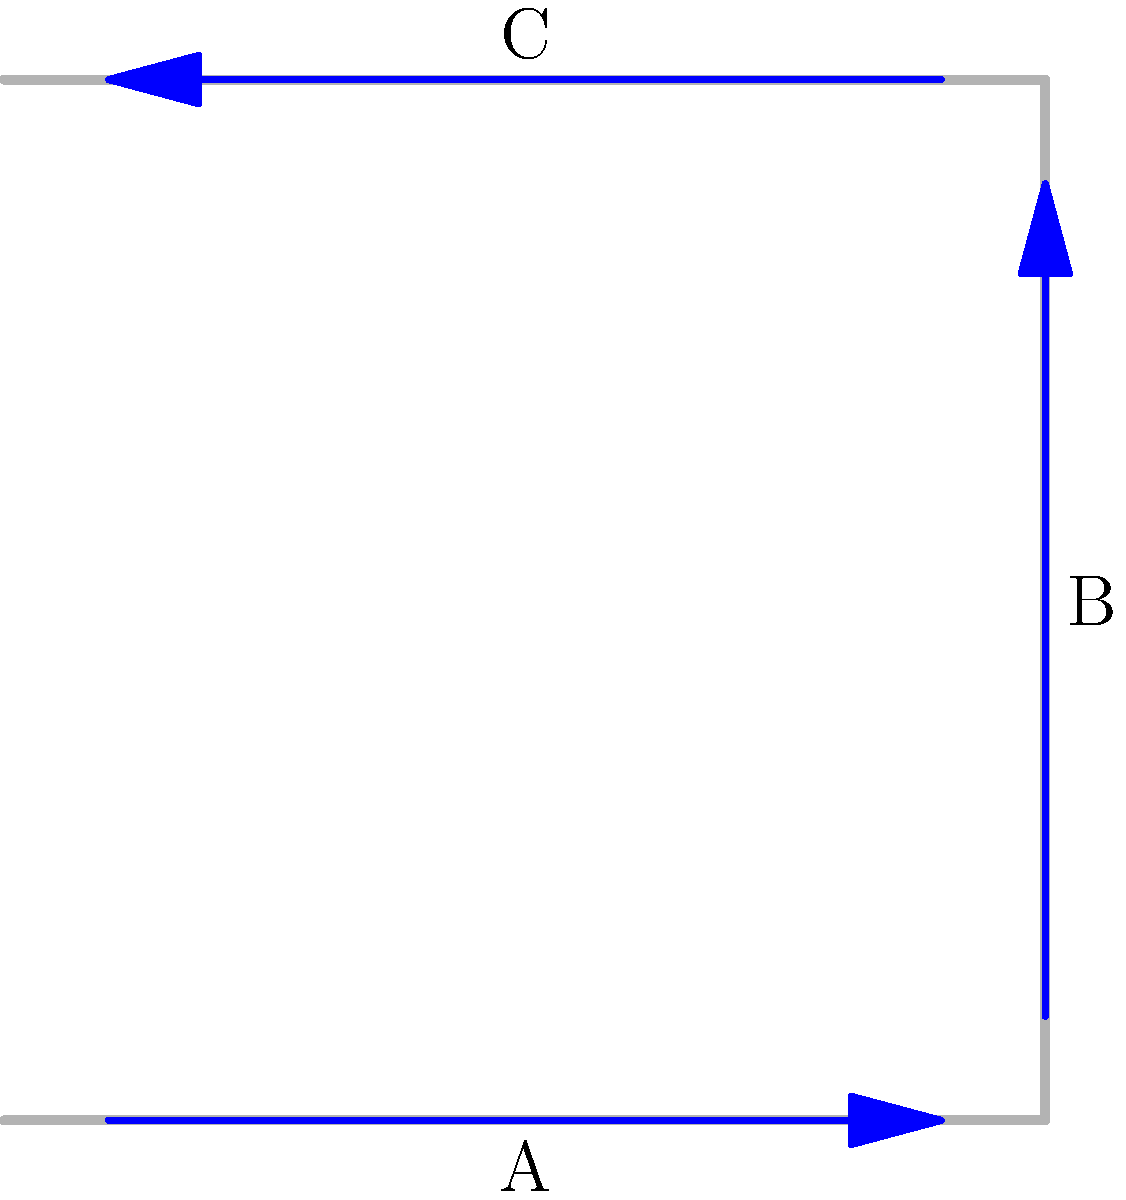In the pipe configuration shown above, fluid flows from point A to point C. Assuming steady, incompressible flow and neglecting friction, how does the fluid velocity at point B compare to the velocities at points A and C? To answer this question, we need to apply the principles of fluid dynamics, specifically the continuity equation and Bernoulli's principle:

1. Continuity Equation: For incompressible flow, the mass flow rate must be constant throughout the system. This means:

   $$Q = A_1v_1 = A_2v_2 = A_3v_3$$

   Where $Q$ is the volumetric flow rate, $A$ is the cross-sectional area, and $v$ is the velocity.

2. Assuming the pipe has a constant diameter, the cross-sectional area is the same at all points (A, B, and C).

3. The flow direction changes at point B, but this doesn't affect the velocity magnitude in an ideal (frictionless) flow.

4. Bernoulli's Principle: For steady, incompressible, frictionless flow along a streamline:

   $$P + \frac{1}{2}\rho v^2 + \rho gh = \text{constant}$$

   Where $P$ is pressure, $\rho$ is density, $v$ is velocity, $g$ is gravitational acceleration, and $h$ is height.

5. In this case, the change in height is negligible compared to the other terms, so we can ignore the $\rho gh$ term.

6. Since the pipe diameter is constant and the flow is incompressible, the velocity must remain constant to satisfy the continuity equation.

Therefore, the velocity at point B must be equal to the velocities at points A and C to maintain a constant flow rate through the system.
Answer: The velocity at point B is equal to the velocities at points A and C. 